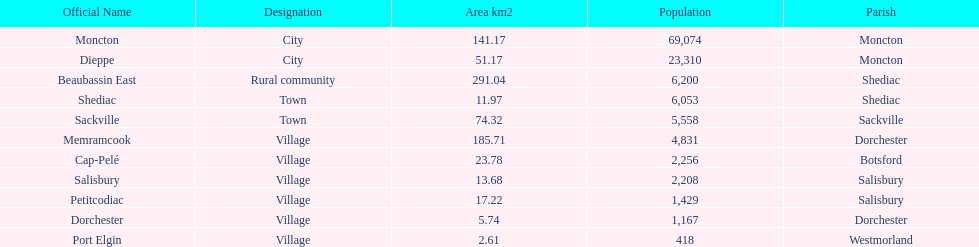Which city has the largest population? Moncton. 